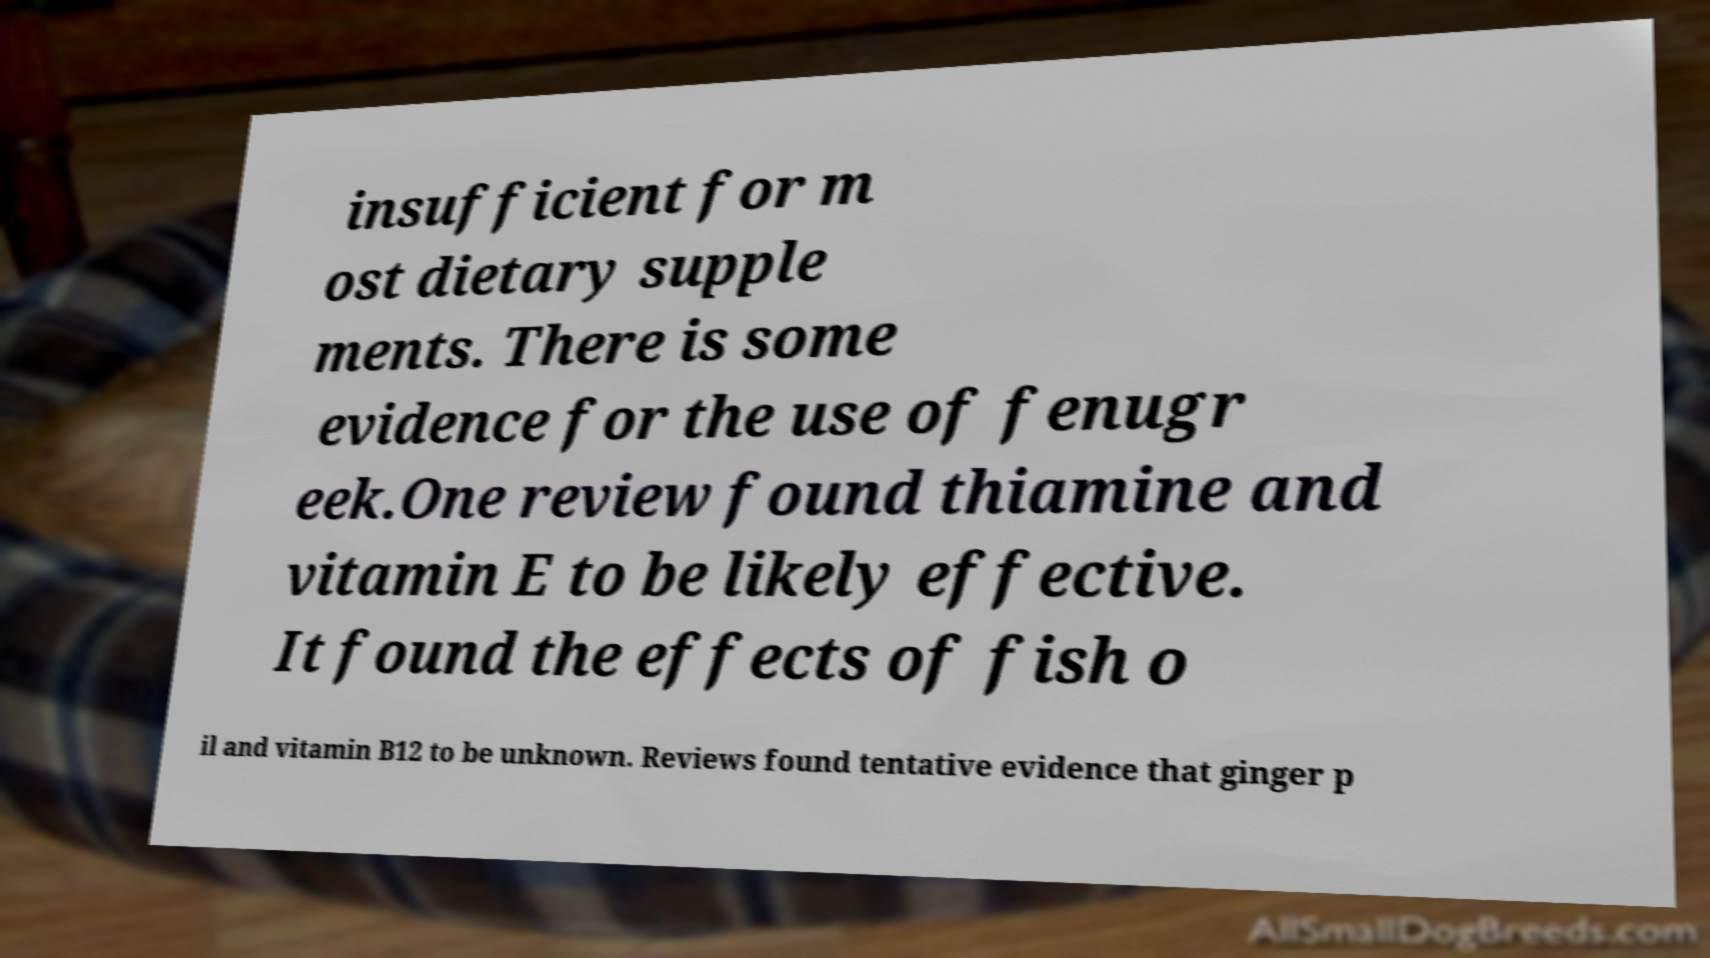Please identify and transcribe the text found in this image. insufficient for m ost dietary supple ments. There is some evidence for the use of fenugr eek.One review found thiamine and vitamin E to be likely effective. It found the effects of fish o il and vitamin B12 to be unknown. Reviews found tentative evidence that ginger p 